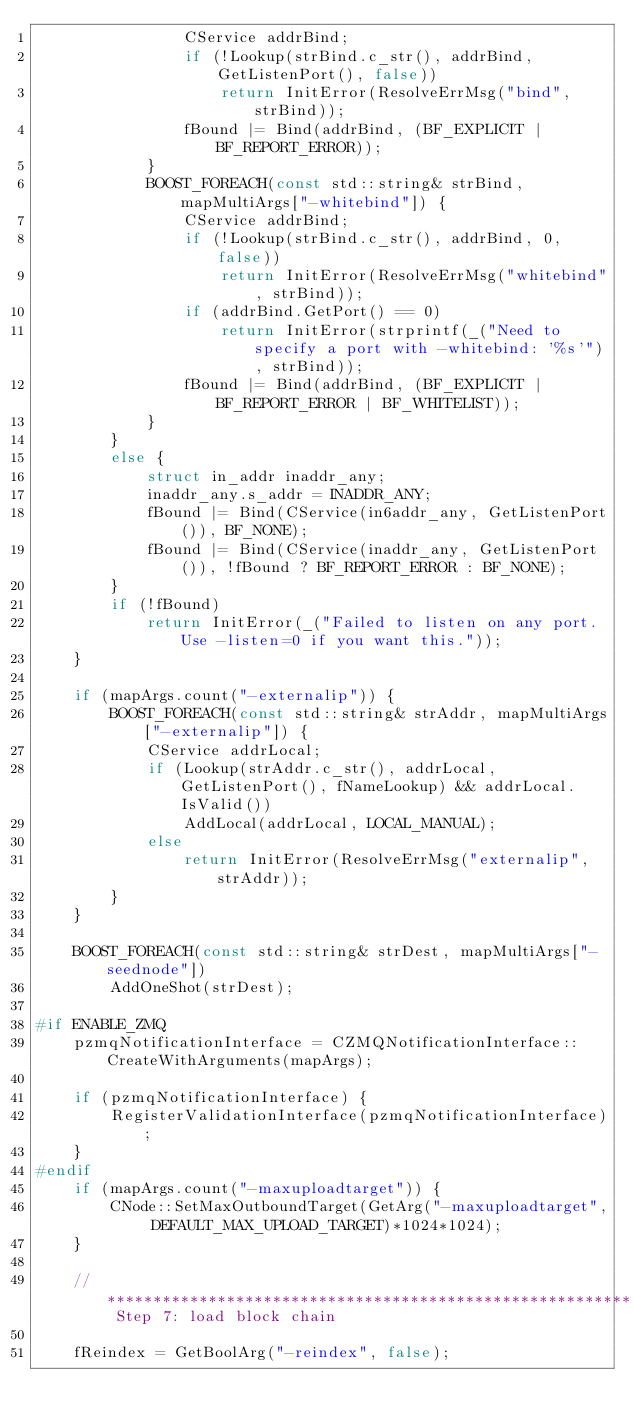Convert code to text. <code><loc_0><loc_0><loc_500><loc_500><_C++_>                CService addrBind;
                if (!Lookup(strBind.c_str(), addrBind, GetListenPort(), false))
                    return InitError(ResolveErrMsg("bind", strBind));
                fBound |= Bind(addrBind, (BF_EXPLICIT | BF_REPORT_ERROR));
            }
            BOOST_FOREACH(const std::string& strBind, mapMultiArgs["-whitebind"]) {
                CService addrBind;
                if (!Lookup(strBind.c_str(), addrBind, 0, false))
                    return InitError(ResolveErrMsg("whitebind", strBind));
                if (addrBind.GetPort() == 0)
                    return InitError(strprintf(_("Need to specify a port with -whitebind: '%s'"), strBind));
                fBound |= Bind(addrBind, (BF_EXPLICIT | BF_REPORT_ERROR | BF_WHITELIST));
            }
        }
        else {
            struct in_addr inaddr_any;
            inaddr_any.s_addr = INADDR_ANY;
            fBound |= Bind(CService(in6addr_any, GetListenPort()), BF_NONE);
            fBound |= Bind(CService(inaddr_any, GetListenPort()), !fBound ? BF_REPORT_ERROR : BF_NONE);
        }
        if (!fBound)
            return InitError(_("Failed to listen on any port. Use -listen=0 if you want this."));
    }

    if (mapArgs.count("-externalip")) {
        BOOST_FOREACH(const std::string& strAddr, mapMultiArgs["-externalip"]) {
            CService addrLocal;
            if (Lookup(strAddr.c_str(), addrLocal, GetListenPort(), fNameLookup) && addrLocal.IsValid())
                AddLocal(addrLocal, LOCAL_MANUAL);
            else
                return InitError(ResolveErrMsg("externalip", strAddr));
        }
    }

    BOOST_FOREACH(const std::string& strDest, mapMultiArgs["-seednode"])
        AddOneShot(strDest);

#if ENABLE_ZMQ
    pzmqNotificationInterface = CZMQNotificationInterface::CreateWithArguments(mapArgs);

    if (pzmqNotificationInterface) {
        RegisterValidationInterface(pzmqNotificationInterface);
    }
#endif
    if (mapArgs.count("-maxuploadtarget")) {
        CNode::SetMaxOutboundTarget(GetArg("-maxuploadtarget", DEFAULT_MAX_UPLOAD_TARGET)*1024*1024);
    }

    // ********************************************************* Step 7: load block chain

    fReindex = GetBoolArg("-reindex", false);</code> 